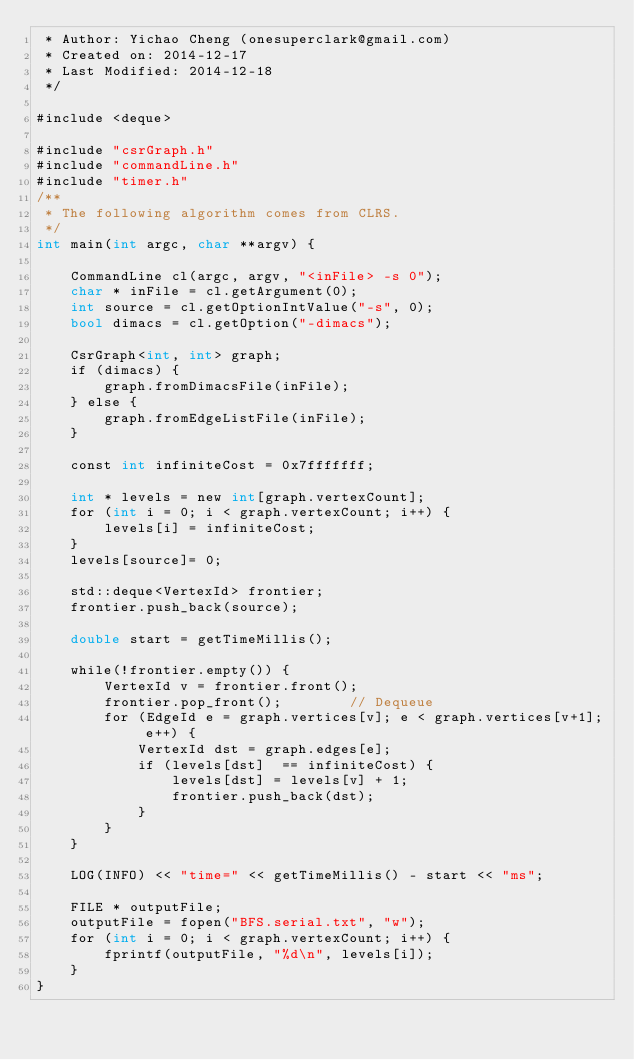Convert code to text. <code><loc_0><loc_0><loc_500><loc_500><_Cuda_> * Author: Yichao Cheng (onesuperclark@gmail.com)
 * Created on: 2014-12-17
 * Last Modified: 2014-12-18
 */

#include <deque>

#include "csrGraph.h"
#include "commandLine.h"
#include "timer.h"
/**
 * The following algorithm comes from CLRS.
 */
int main(int argc, char **argv) {

    CommandLine cl(argc, argv, "<inFile> -s 0");
    char * inFile = cl.getArgument(0);
    int source = cl.getOptionIntValue("-s", 0);
    bool dimacs = cl.getOption("-dimacs");

    CsrGraph<int, int> graph;
    if (dimacs) {
        graph.fromDimacsFile(inFile);
    } else {
        graph.fromEdgeListFile(inFile);
    }

    const int infiniteCost = 0x7fffffff;

    int * levels = new int[graph.vertexCount];
    for (int i = 0; i < graph.vertexCount; i++) {
        levels[i] = infiniteCost;
    }
    levels[source]= 0;

    std::deque<VertexId> frontier;
    frontier.push_back(source);

    double start = getTimeMillis();

    while(!frontier.empty()) {
        VertexId v = frontier.front();
        frontier.pop_front();        // Dequeue
        for (EdgeId e = graph.vertices[v]; e < graph.vertices[v+1]; e++) {
            VertexId dst = graph.edges[e];
            if (levels[dst]  == infiniteCost) {
                levels[dst] = levels[v] + 1; 
                frontier.push_back(dst);
            }
        }
    }

    LOG(INFO) << "time=" << getTimeMillis() - start << "ms";

    FILE * outputFile;
    outputFile = fopen("BFS.serial.txt", "w");
    for (int i = 0; i < graph.vertexCount; i++) {
        fprintf(outputFile, "%d\n", levels[i]);
    }
}</code> 